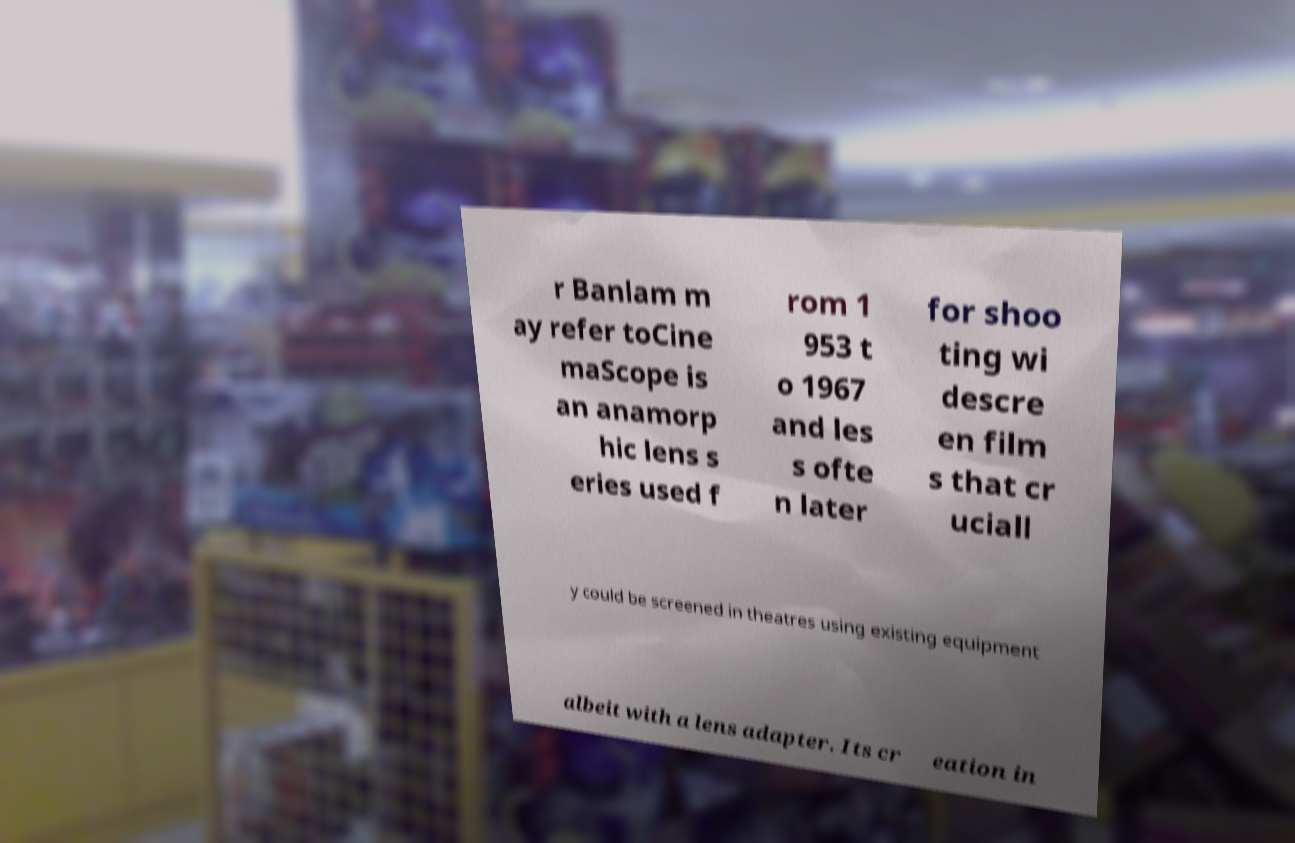Can you accurately transcribe the text from the provided image for me? r Banlam m ay refer toCine maScope is an anamorp hic lens s eries used f rom 1 953 t o 1967 and les s ofte n later for shoo ting wi descre en film s that cr uciall y could be screened in theatres using existing equipment albeit with a lens adapter. Its cr eation in 